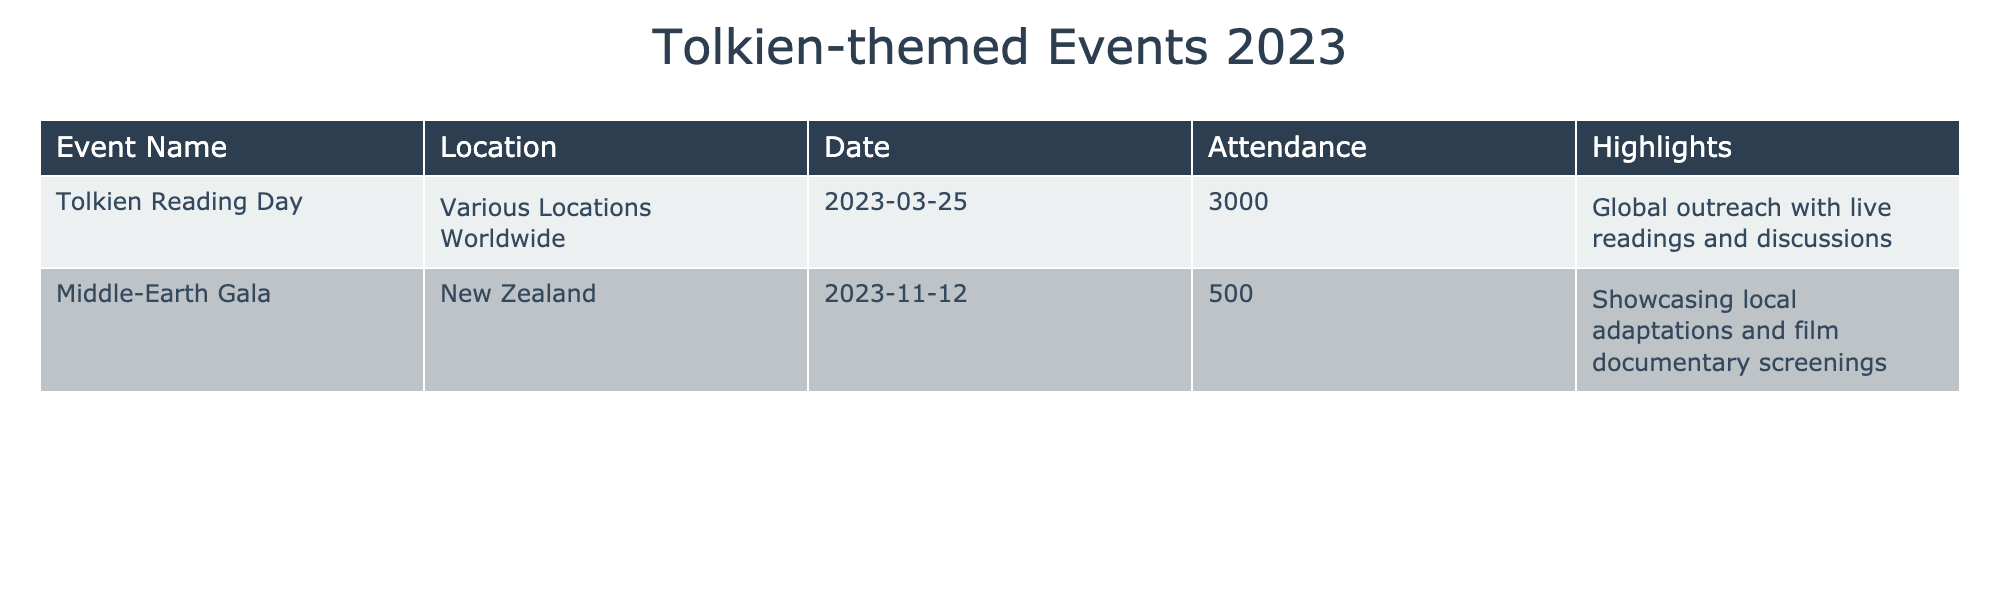What is the total attendance for the Tolkien-themed events listed in the table? To find the total attendance, we need to sum the attendance figures from both events: 3000 (Tolkien Reading Day) + 500 (Middle-Earth Gala) = 3500.
Answer: 3500 Which event had the highest attendance? The Tolkien Reading Day had an attendance of 3000, while the Middle-Earth Gala had an attendance of 500. Therefore, the Tolkien Reading Day had the highest attendance.
Answer: Tolkien Reading Day Did any of the events focus on adaptations of Tolkien's work? The Middle-Earth Gala specifically mentioned showcasing local adaptations, while the Tolkien Reading Day did not mention this focus. Thus, the answer is yes.
Answer: Yes What date did the Tolkien Reading Day occur? The date for the Tolkien Reading Day is listed as March 25, 2023, in the table.
Answer: March 25, 2023 If we compare both events, what is the difference in attendance between the Tolkien Reading Day and the Middle-Earth Gala? The attendance for the Tolkien Reading Day is 3000, and for the Middle-Earth Gala, it is 500. The difference is calculated as 3000 - 500 = 2500.
Answer: 2500 Which location hosted the Middle-Earth Gala? The table specifies that the Middle-Earth Gala was held in New Zealand.
Answer: New Zealand How many events were held on the same date? The table lists two events, and each took place on different dates (March 25 and November 12). Thus, the answer is zero events on the same date.
Answer: 0 What unique feature does the Tolkien Reading Day highlight? The table notes that the Tolkien Reading Day focuses on global outreach with live readings and discussions as its unique feature.
Answer: Global outreach with live readings and discussions What is the significance of the dates for the events in relation to Tolkien's legacy? The Tolkien Reading Day is specifically recognized as a day to celebrate Tolkien’s works, while the Middle-Earth Gala, occurring later in the year, focuses on adaptations. Both events are significant in honoring his legacy at different times.
Answer: Significant in honoring Tolkien's legacy at different times 